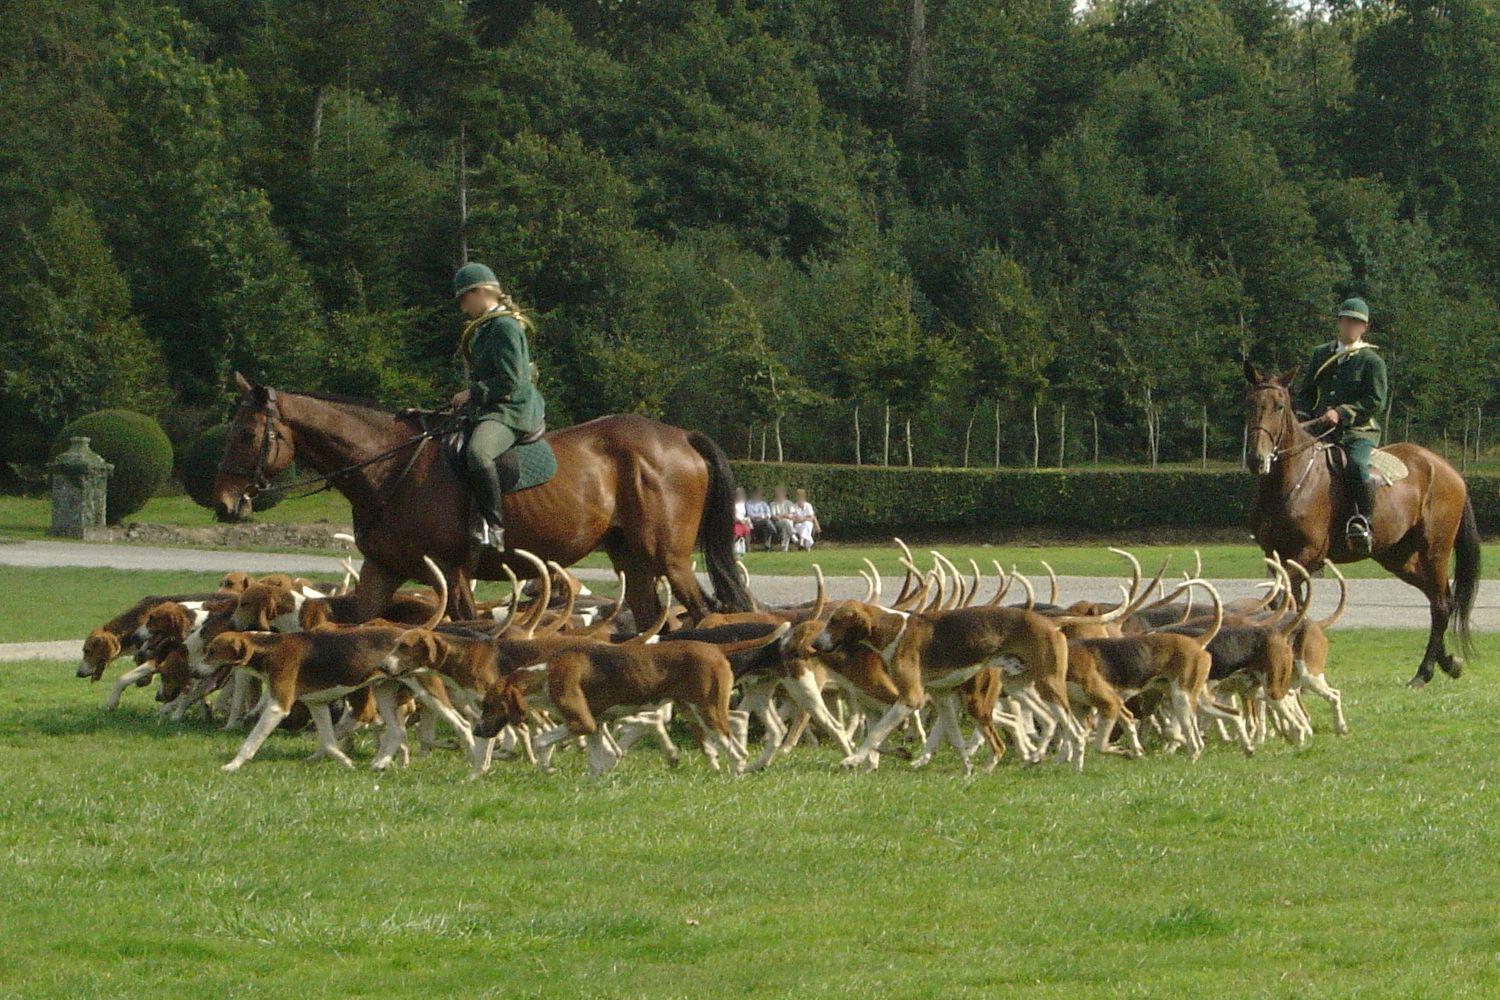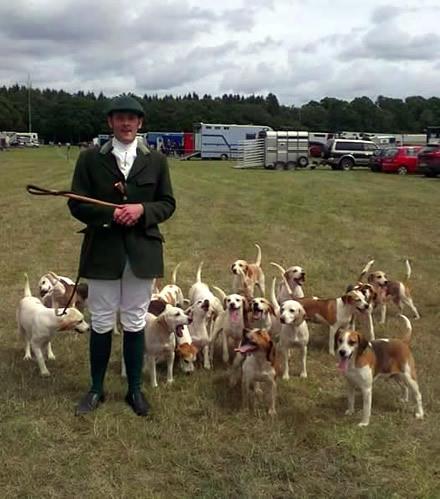The first image is the image on the left, the second image is the image on the right. For the images displayed, is the sentence "At least one horse is present with a group of hounds in one image." factually correct? Answer yes or no. Yes. The first image is the image on the left, the second image is the image on the right. Assess this claim about the two images: "A horse is in a grassy area with a group of dogs.". Correct or not? Answer yes or no. Yes. 